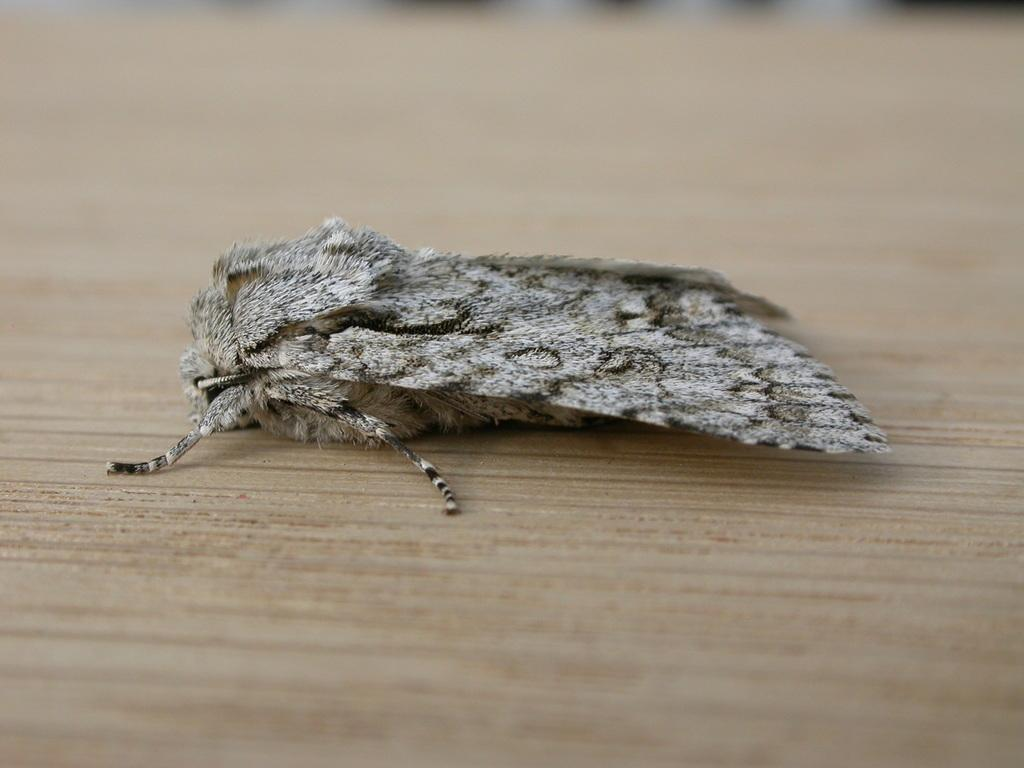What type of insect is in the image? There is a peppered moth in the image. Where is the moth located? The moth is on a table. How many moths are in the image? There is only one moth in the image, which is a peppered moth. What type of knowledge can be gained from observing the moth's behavior in the image? There is no behavior to observe in the image, as the moth is stationary on the table. 